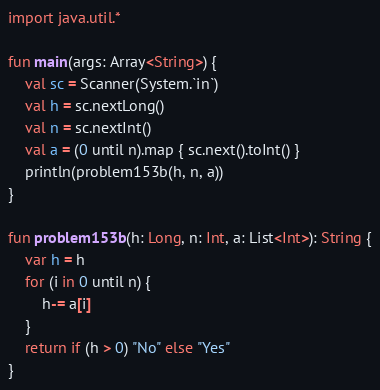Convert code to text. <code><loc_0><loc_0><loc_500><loc_500><_Kotlin_>import java.util.*

fun main(args: Array<String>) {
    val sc = Scanner(System.`in`)
    val h = sc.nextLong()
    val n = sc.nextInt()
    val a = (0 until n).map { sc.next().toInt() }
    println(problem153b(h, n, a))
}

fun problem153b(h: Long, n: Int, a: List<Int>): String {
    var h = h
    for (i in 0 until n) {
        h-= a[i]
    }
    return if (h > 0) "No" else "Yes"
}</code> 